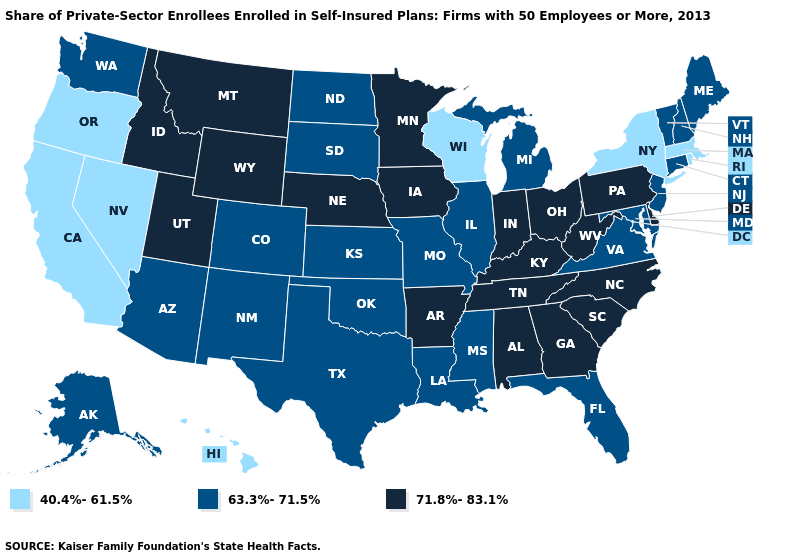What is the value of Michigan?
Keep it brief. 63.3%-71.5%. Name the states that have a value in the range 71.8%-83.1%?
Give a very brief answer. Alabama, Arkansas, Delaware, Georgia, Idaho, Indiana, Iowa, Kentucky, Minnesota, Montana, Nebraska, North Carolina, Ohio, Pennsylvania, South Carolina, Tennessee, Utah, West Virginia, Wyoming. Among the states that border Idaho , which have the highest value?
Keep it brief. Montana, Utah, Wyoming. Among the states that border Louisiana , does Arkansas have the lowest value?
Short answer required. No. What is the lowest value in the Northeast?
Keep it brief. 40.4%-61.5%. Name the states that have a value in the range 71.8%-83.1%?
Quick response, please. Alabama, Arkansas, Delaware, Georgia, Idaho, Indiana, Iowa, Kentucky, Minnesota, Montana, Nebraska, North Carolina, Ohio, Pennsylvania, South Carolina, Tennessee, Utah, West Virginia, Wyoming. Among the states that border Missouri , which have the lowest value?
Answer briefly. Illinois, Kansas, Oklahoma. Does Georgia have the lowest value in the USA?
Write a very short answer. No. Does the map have missing data?
Be succinct. No. Among the states that border Tennessee , which have the highest value?
Answer briefly. Alabama, Arkansas, Georgia, Kentucky, North Carolina. What is the lowest value in the USA?
Keep it brief. 40.4%-61.5%. Is the legend a continuous bar?
Write a very short answer. No. What is the value of Missouri?
Concise answer only. 63.3%-71.5%. Name the states that have a value in the range 40.4%-61.5%?
Concise answer only. California, Hawaii, Massachusetts, Nevada, New York, Oregon, Rhode Island, Wisconsin. What is the lowest value in states that border Alabama?
Quick response, please. 63.3%-71.5%. 